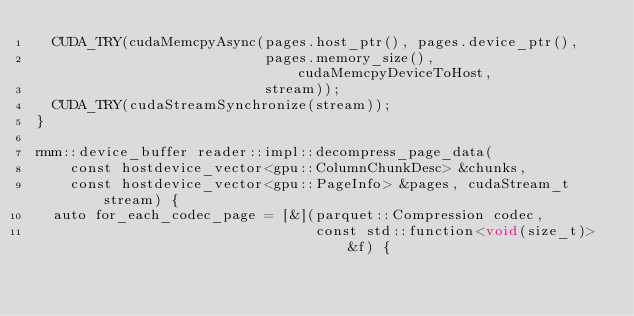Convert code to text. <code><loc_0><loc_0><loc_500><loc_500><_Cuda_>  CUDA_TRY(cudaMemcpyAsync(pages.host_ptr(), pages.device_ptr(),
                           pages.memory_size(), cudaMemcpyDeviceToHost,
                           stream));
  CUDA_TRY(cudaStreamSynchronize(stream));
}

rmm::device_buffer reader::impl::decompress_page_data(
    const hostdevice_vector<gpu::ColumnChunkDesc> &chunks,
    const hostdevice_vector<gpu::PageInfo> &pages, cudaStream_t stream) {
  auto for_each_codec_page = [&](parquet::Compression codec,
                                 const std::function<void(size_t)> &f) {</code> 